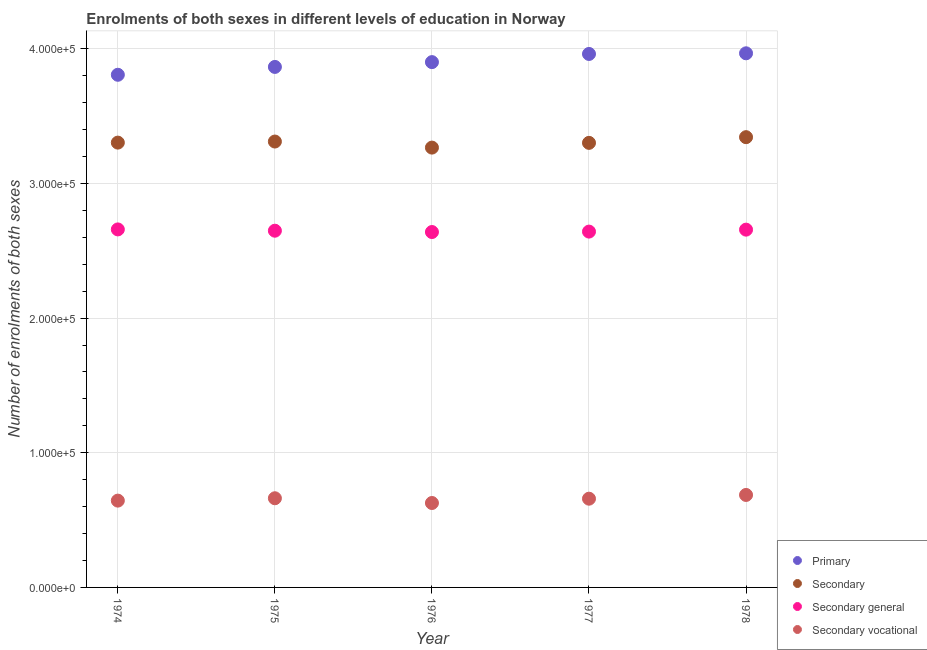How many different coloured dotlines are there?
Keep it short and to the point. 4. What is the number of enrolments in primary education in 1974?
Offer a very short reply. 3.81e+05. Across all years, what is the maximum number of enrolments in secondary education?
Offer a very short reply. 3.34e+05. Across all years, what is the minimum number of enrolments in secondary general education?
Make the answer very short. 2.64e+05. In which year was the number of enrolments in primary education maximum?
Your answer should be compact. 1978. In which year was the number of enrolments in primary education minimum?
Ensure brevity in your answer.  1974. What is the total number of enrolments in secondary education in the graph?
Offer a terse response. 1.65e+06. What is the difference between the number of enrolments in secondary general education in 1975 and that in 1978?
Give a very brief answer. -789. What is the difference between the number of enrolments in secondary vocational education in 1975 and the number of enrolments in secondary education in 1977?
Ensure brevity in your answer.  -2.64e+05. What is the average number of enrolments in secondary vocational education per year?
Your response must be concise. 6.56e+04. In the year 1974, what is the difference between the number of enrolments in primary education and number of enrolments in secondary general education?
Ensure brevity in your answer.  1.15e+05. What is the ratio of the number of enrolments in secondary vocational education in 1975 to that in 1978?
Your answer should be very brief. 0.96. Is the number of enrolments in primary education in 1975 less than that in 1978?
Your answer should be compact. Yes. What is the difference between the highest and the second highest number of enrolments in secondary general education?
Your answer should be very brief. 170. What is the difference between the highest and the lowest number of enrolments in secondary general education?
Provide a short and direct response. 1943. In how many years, is the number of enrolments in secondary general education greater than the average number of enrolments in secondary general education taken over all years?
Your response must be concise. 2. Is the sum of the number of enrolments in secondary vocational education in 1975 and 1978 greater than the maximum number of enrolments in secondary general education across all years?
Provide a short and direct response. No. Is the number of enrolments in secondary vocational education strictly greater than the number of enrolments in secondary general education over the years?
Ensure brevity in your answer.  No. How many dotlines are there?
Provide a short and direct response. 4. How many years are there in the graph?
Your response must be concise. 5. What is the difference between two consecutive major ticks on the Y-axis?
Provide a short and direct response. 1.00e+05. Does the graph contain any zero values?
Offer a very short reply. No. Where does the legend appear in the graph?
Your response must be concise. Bottom right. What is the title of the graph?
Your answer should be very brief. Enrolments of both sexes in different levels of education in Norway. What is the label or title of the X-axis?
Your answer should be compact. Year. What is the label or title of the Y-axis?
Keep it short and to the point. Number of enrolments of both sexes. What is the Number of enrolments of both sexes in Primary in 1974?
Your answer should be very brief. 3.81e+05. What is the Number of enrolments of both sexes in Secondary in 1974?
Your answer should be very brief. 3.30e+05. What is the Number of enrolments of both sexes of Secondary general in 1974?
Offer a very short reply. 2.66e+05. What is the Number of enrolments of both sexes in Secondary vocational in 1974?
Ensure brevity in your answer.  6.45e+04. What is the Number of enrolments of both sexes of Primary in 1975?
Ensure brevity in your answer.  3.87e+05. What is the Number of enrolments of both sexes in Secondary in 1975?
Your response must be concise. 3.31e+05. What is the Number of enrolments of both sexes in Secondary general in 1975?
Provide a succinct answer. 2.65e+05. What is the Number of enrolments of both sexes in Secondary vocational in 1975?
Your answer should be very brief. 6.62e+04. What is the Number of enrolments of both sexes in Primary in 1976?
Give a very brief answer. 3.90e+05. What is the Number of enrolments of both sexes in Secondary in 1976?
Offer a terse response. 3.27e+05. What is the Number of enrolments of both sexes of Secondary general in 1976?
Ensure brevity in your answer.  2.64e+05. What is the Number of enrolments of both sexes of Secondary vocational in 1976?
Give a very brief answer. 6.27e+04. What is the Number of enrolments of both sexes in Primary in 1977?
Offer a very short reply. 3.96e+05. What is the Number of enrolments of both sexes in Secondary in 1977?
Ensure brevity in your answer.  3.30e+05. What is the Number of enrolments of both sexes of Secondary general in 1977?
Your response must be concise. 2.64e+05. What is the Number of enrolments of both sexes in Secondary vocational in 1977?
Your answer should be compact. 6.59e+04. What is the Number of enrolments of both sexes in Primary in 1978?
Ensure brevity in your answer.  3.97e+05. What is the Number of enrolments of both sexes of Secondary in 1978?
Ensure brevity in your answer.  3.34e+05. What is the Number of enrolments of both sexes in Secondary general in 1978?
Make the answer very short. 2.66e+05. What is the Number of enrolments of both sexes of Secondary vocational in 1978?
Your answer should be compact. 6.87e+04. Across all years, what is the maximum Number of enrolments of both sexes in Primary?
Make the answer very short. 3.97e+05. Across all years, what is the maximum Number of enrolments of both sexes of Secondary?
Your answer should be very brief. 3.34e+05. Across all years, what is the maximum Number of enrolments of both sexes in Secondary general?
Your answer should be very brief. 2.66e+05. Across all years, what is the maximum Number of enrolments of both sexes of Secondary vocational?
Provide a short and direct response. 6.87e+04. Across all years, what is the minimum Number of enrolments of both sexes in Primary?
Your answer should be compact. 3.81e+05. Across all years, what is the minimum Number of enrolments of both sexes of Secondary?
Provide a short and direct response. 3.27e+05. Across all years, what is the minimum Number of enrolments of both sexes of Secondary general?
Your answer should be compact. 2.64e+05. Across all years, what is the minimum Number of enrolments of both sexes of Secondary vocational?
Provide a succinct answer. 6.27e+04. What is the total Number of enrolments of both sexes of Primary in the graph?
Your answer should be very brief. 1.95e+06. What is the total Number of enrolments of both sexes of Secondary in the graph?
Make the answer very short. 1.65e+06. What is the total Number of enrolments of both sexes of Secondary general in the graph?
Make the answer very short. 1.32e+06. What is the total Number of enrolments of both sexes of Secondary vocational in the graph?
Your answer should be very brief. 3.28e+05. What is the difference between the Number of enrolments of both sexes in Primary in 1974 and that in 1975?
Your answer should be compact. -5831. What is the difference between the Number of enrolments of both sexes in Secondary in 1974 and that in 1975?
Offer a very short reply. -799. What is the difference between the Number of enrolments of both sexes of Secondary general in 1974 and that in 1975?
Offer a very short reply. 959. What is the difference between the Number of enrolments of both sexes in Secondary vocational in 1974 and that in 1975?
Provide a short and direct response. -1758. What is the difference between the Number of enrolments of both sexes of Primary in 1974 and that in 1976?
Your answer should be compact. -9401. What is the difference between the Number of enrolments of both sexes in Secondary in 1974 and that in 1976?
Provide a short and direct response. 3710. What is the difference between the Number of enrolments of both sexes in Secondary general in 1974 and that in 1976?
Your response must be concise. 1943. What is the difference between the Number of enrolments of both sexes of Secondary vocational in 1974 and that in 1976?
Make the answer very short. 1767. What is the difference between the Number of enrolments of both sexes of Primary in 1974 and that in 1977?
Provide a succinct answer. -1.55e+04. What is the difference between the Number of enrolments of both sexes of Secondary in 1974 and that in 1977?
Keep it short and to the point. 187. What is the difference between the Number of enrolments of both sexes of Secondary general in 1974 and that in 1977?
Offer a very short reply. 1621. What is the difference between the Number of enrolments of both sexes of Secondary vocational in 1974 and that in 1977?
Keep it short and to the point. -1434. What is the difference between the Number of enrolments of both sexes of Primary in 1974 and that in 1978?
Keep it short and to the point. -1.59e+04. What is the difference between the Number of enrolments of both sexes of Secondary in 1974 and that in 1978?
Make the answer very short. -4042. What is the difference between the Number of enrolments of both sexes of Secondary general in 1974 and that in 1978?
Your answer should be very brief. 170. What is the difference between the Number of enrolments of both sexes in Secondary vocational in 1974 and that in 1978?
Your response must be concise. -4212. What is the difference between the Number of enrolments of both sexes in Primary in 1975 and that in 1976?
Give a very brief answer. -3570. What is the difference between the Number of enrolments of both sexes in Secondary in 1975 and that in 1976?
Make the answer very short. 4509. What is the difference between the Number of enrolments of both sexes of Secondary general in 1975 and that in 1976?
Your answer should be compact. 984. What is the difference between the Number of enrolments of both sexes of Secondary vocational in 1975 and that in 1976?
Offer a very short reply. 3525. What is the difference between the Number of enrolments of both sexes of Primary in 1975 and that in 1977?
Ensure brevity in your answer.  -9635. What is the difference between the Number of enrolments of both sexes in Secondary in 1975 and that in 1977?
Ensure brevity in your answer.  986. What is the difference between the Number of enrolments of both sexes in Secondary general in 1975 and that in 1977?
Make the answer very short. 662. What is the difference between the Number of enrolments of both sexes in Secondary vocational in 1975 and that in 1977?
Ensure brevity in your answer.  324. What is the difference between the Number of enrolments of both sexes of Primary in 1975 and that in 1978?
Offer a terse response. -1.01e+04. What is the difference between the Number of enrolments of both sexes of Secondary in 1975 and that in 1978?
Offer a terse response. -3243. What is the difference between the Number of enrolments of both sexes in Secondary general in 1975 and that in 1978?
Offer a very short reply. -789. What is the difference between the Number of enrolments of both sexes in Secondary vocational in 1975 and that in 1978?
Ensure brevity in your answer.  -2454. What is the difference between the Number of enrolments of both sexes of Primary in 1976 and that in 1977?
Keep it short and to the point. -6065. What is the difference between the Number of enrolments of both sexes of Secondary in 1976 and that in 1977?
Your response must be concise. -3523. What is the difference between the Number of enrolments of both sexes of Secondary general in 1976 and that in 1977?
Offer a very short reply. -322. What is the difference between the Number of enrolments of both sexes of Secondary vocational in 1976 and that in 1977?
Provide a succinct answer. -3201. What is the difference between the Number of enrolments of both sexes in Primary in 1976 and that in 1978?
Keep it short and to the point. -6543. What is the difference between the Number of enrolments of both sexes in Secondary in 1976 and that in 1978?
Make the answer very short. -7752. What is the difference between the Number of enrolments of both sexes in Secondary general in 1976 and that in 1978?
Keep it short and to the point. -1773. What is the difference between the Number of enrolments of both sexes of Secondary vocational in 1976 and that in 1978?
Provide a short and direct response. -5979. What is the difference between the Number of enrolments of both sexes of Primary in 1977 and that in 1978?
Keep it short and to the point. -478. What is the difference between the Number of enrolments of both sexes of Secondary in 1977 and that in 1978?
Ensure brevity in your answer.  -4229. What is the difference between the Number of enrolments of both sexes in Secondary general in 1977 and that in 1978?
Give a very brief answer. -1451. What is the difference between the Number of enrolments of both sexes of Secondary vocational in 1977 and that in 1978?
Make the answer very short. -2778. What is the difference between the Number of enrolments of both sexes of Primary in 1974 and the Number of enrolments of both sexes of Secondary in 1975?
Offer a terse response. 4.96e+04. What is the difference between the Number of enrolments of both sexes of Primary in 1974 and the Number of enrolments of both sexes of Secondary general in 1975?
Provide a succinct answer. 1.16e+05. What is the difference between the Number of enrolments of both sexes of Primary in 1974 and the Number of enrolments of both sexes of Secondary vocational in 1975?
Ensure brevity in your answer.  3.15e+05. What is the difference between the Number of enrolments of both sexes of Secondary in 1974 and the Number of enrolments of both sexes of Secondary general in 1975?
Your answer should be very brief. 6.54e+04. What is the difference between the Number of enrolments of both sexes of Secondary in 1974 and the Number of enrolments of both sexes of Secondary vocational in 1975?
Your answer should be compact. 2.64e+05. What is the difference between the Number of enrolments of both sexes in Secondary general in 1974 and the Number of enrolments of both sexes in Secondary vocational in 1975?
Provide a short and direct response. 2.00e+05. What is the difference between the Number of enrolments of both sexes in Primary in 1974 and the Number of enrolments of both sexes in Secondary in 1976?
Offer a very short reply. 5.41e+04. What is the difference between the Number of enrolments of both sexes in Primary in 1974 and the Number of enrolments of both sexes in Secondary general in 1976?
Provide a succinct answer. 1.17e+05. What is the difference between the Number of enrolments of both sexes of Primary in 1974 and the Number of enrolments of both sexes of Secondary vocational in 1976?
Keep it short and to the point. 3.18e+05. What is the difference between the Number of enrolments of both sexes in Secondary in 1974 and the Number of enrolments of both sexes in Secondary general in 1976?
Provide a succinct answer. 6.64e+04. What is the difference between the Number of enrolments of both sexes in Secondary in 1974 and the Number of enrolments of both sexes in Secondary vocational in 1976?
Make the answer very short. 2.68e+05. What is the difference between the Number of enrolments of both sexes of Secondary general in 1974 and the Number of enrolments of both sexes of Secondary vocational in 1976?
Your response must be concise. 2.03e+05. What is the difference between the Number of enrolments of both sexes of Primary in 1974 and the Number of enrolments of both sexes of Secondary in 1977?
Your answer should be compact. 5.06e+04. What is the difference between the Number of enrolments of both sexes of Primary in 1974 and the Number of enrolments of both sexes of Secondary general in 1977?
Your response must be concise. 1.16e+05. What is the difference between the Number of enrolments of both sexes in Primary in 1974 and the Number of enrolments of both sexes in Secondary vocational in 1977?
Offer a very short reply. 3.15e+05. What is the difference between the Number of enrolments of both sexes of Secondary in 1974 and the Number of enrolments of both sexes of Secondary general in 1977?
Make the answer very short. 6.61e+04. What is the difference between the Number of enrolments of both sexes of Secondary in 1974 and the Number of enrolments of both sexes of Secondary vocational in 1977?
Offer a very short reply. 2.64e+05. What is the difference between the Number of enrolments of both sexes of Secondary general in 1974 and the Number of enrolments of both sexes of Secondary vocational in 1977?
Your answer should be very brief. 2.00e+05. What is the difference between the Number of enrolments of both sexes of Primary in 1974 and the Number of enrolments of both sexes of Secondary in 1978?
Make the answer very short. 4.63e+04. What is the difference between the Number of enrolments of both sexes of Primary in 1974 and the Number of enrolments of both sexes of Secondary general in 1978?
Provide a short and direct response. 1.15e+05. What is the difference between the Number of enrolments of both sexes of Primary in 1974 and the Number of enrolments of both sexes of Secondary vocational in 1978?
Provide a succinct answer. 3.12e+05. What is the difference between the Number of enrolments of both sexes in Secondary in 1974 and the Number of enrolments of both sexes in Secondary general in 1978?
Ensure brevity in your answer.  6.46e+04. What is the difference between the Number of enrolments of both sexes in Secondary in 1974 and the Number of enrolments of both sexes in Secondary vocational in 1978?
Your response must be concise. 2.62e+05. What is the difference between the Number of enrolments of both sexes of Secondary general in 1974 and the Number of enrolments of both sexes of Secondary vocational in 1978?
Provide a short and direct response. 1.97e+05. What is the difference between the Number of enrolments of both sexes of Primary in 1975 and the Number of enrolments of both sexes of Secondary in 1976?
Offer a terse response. 5.99e+04. What is the difference between the Number of enrolments of both sexes of Primary in 1975 and the Number of enrolments of both sexes of Secondary general in 1976?
Make the answer very short. 1.23e+05. What is the difference between the Number of enrolments of both sexes in Primary in 1975 and the Number of enrolments of both sexes in Secondary vocational in 1976?
Provide a succinct answer. 3.24e+05. What is the difference between the Number of enrolments of both sexes in Secondary in 1975 and the Number of enrolments of both sexes in Secondary general in 1976?
Your response must be concise. 6.72e+04. What is the difference between the Number of enrolments of both sexes of Secondary in 1975 and the Number of enrolments of both sexes of Secondary vocational in 1976?
Make the answer very short. 2.68e+05. What is the difference between the Number of enrolments of both sexes in Secondary general in 1975 and the Number of enrolments of both sexes in Secondary vocational in 1976?
Ensure brevity in your answer.  2.02e+05. What is the difference between the Number of enrolments of both sexes in Primary in 1975 and the Number of enrolments of both sexes in Secondary in 1977?
Provide a succinct answer. 5.64e+04. What is the difference between the Number of enrolments of both sexes in Primary in 1975 and the Number of enrolments of both sexes in Secondary general in 1977?
Your response must be concise. 1.22e+05. What is the difference between the Number of enrolments of both sexes of Primary in 1975 and the Number of enrolments of both sexes of Secondary vocational in 1977?
Your response must be concise. 3.21e+05. What is the difference between the Number of enrolments of both sexes in Secondary in 1975 and the Number of enrolments of both sexes in Secondary general in 1977?
Offer a very short reply. 6.69e+04. What is the difference between the Number of enrolments of both sexes in Secondary in 1975 and the Number of enrolments of both sexes in Secondary vocational in 1977?
Make the answer very short. 2.65e+05. What is the difference between the Number of enrolments of both sexes of Secondary general in 1975 and the Number of enrolments of both sexes of Secondary vocational in 1977?
Ensure brevity in your answer.  1.99e+05. What is the difference between the Number of enrolments of both sexes in Primary in 1975 and the Number of enrolments of both sexes in Secondary in 1978?
Offer a very short reply. 5.22e+04. What is the difference between the Number of enrolments of both sexes in Primary in 1975 and the Number of enrolments of both sexes in Secondary general in 1978?
Give a very brief answer. 1.21e+05. What is the difference between the Number of enrolments of both sexes of Primary in 1975 and the Number of enrolments of both sexes of Secondary vocational in 1978?
Provide a succinct answer. 3.18e+05. What is the difference between the Number of enrolments of both sexes of Secondary in 1975 and the Number of enrolments of both sexes of Secondary general in 1978?
Ensure brevity in your answer.  6.54e+04. What is the difference between the Number of enrolments of both sexes of Secondary in 1975 and the Number of enrolments of both sexes of Secondary vocational in 1978?
Your answer should be very brief. 2.62e+05. What is the difference between the Number of enrolments of both sexes of Secondary general in 1975 and the Number of enrolments of both sexes of Secondary vocational in 1978?
Ensure brevity in your answer.  1.96e+05. What is the difference between the Number of enrolments of both sexes in Primary in 1976 and the Number of enrolments of both sexes in Secondary in 1977?
Make the answer very short. 6.00e+04. What is the difference between the Number of enrolments of both sexes of Primary in 1976 and the Number of enrolments of both sexes of Secondary general in 1977?
Your answer should be compact. 1.26e+05. What is the difference between the Number of enrolments of both sexes of Primary in 1976 and the Number of enrolments of both sexes of Secondary vocational in 1977?
Make the answer very short. 3.24e+05. What is the difference between the Number of enrolments of both sexes in Secondary in 1976 and the Number of enrolments of both sexes in Secondary general in 1977?
Your answer should be compact. 6.24e+04. What is the difference between the Number of enrolments of both sexes of Secondary in 1976 and the Number of enrolments of both sexes of Secondary vocational in 1977?
Offer a terse response. 2.61e+05. What is the difference between the Number of enrolments of both sexes in Secondary general in 1976 and the Number of enrolments of both sexes in Secondary vocational in 1977?
Your response must be concise. 1.98e+05. What is the difference between the Number of enrolments of both sexes in Primary in 1976 and the Number of enrolments of both sexes in Secondary in 1978?
Give a very brief answer. 5.57e+04. What is the difference between the Number of enrolments of both sexes in Primary in 1976 and the Number of enrolments of both sexes in Secondary general in 1978?
Offer a very short reply. 1.24e+05. What is the difference between the Number of enrolments of both sexes of Primary in 1976 and the Number of enrolments of both sexes of Secondary vocational in 1978?
Keep it short and to the point. 3.21e+05. What is the difference between the Number of enrolments of both sexes of Secondary in 1976 and the Number of enrolments of both sexes of Secondary general in 1978?
Give a very brief answer. 6.09e+04. What is the difference between the Number of enrolments of both sexes of Secondary in 1976 and the Number of enrolments of both sexes of Secondary vocational in 1978?
Offer a terse response. 2.58e+05. What is the difference between the Number of enrolments of both sexes of Secondary general in 1976 and the Number of enrolments of both sexes of Secondary vocational in 1978?
Provide a succinct answer. 1.95e+05. What is the difference between the Number of enrolments of both sexes of Primary in 1977 and the Number of enrolments of both sexes of Secondary in 1978?
Your answer should be very brief. 6.18e+04. What is the difference between the Number of enrolments of both sexes in Primary in 1977 and the Number of enrolments of both sexes in Secondary general in 1978?
Provide a short and direct response. 1.30e+05. What is the difference between the Number of enrolments of both sexes in Primary in 1977 and the Number of enrolments of both sexes in Secondary vocational in 1978?
Your response must be concise. 3.28e+05. What is the difference between the Number of enrolments of both sexes in Secondary in 1977 and the Number of enrolments of both sexes in Secondary general in 1978?
Give a very brief answer. 6.44e+04. What is the difference between the Number of enrolments of both sexes in Secondary in 1977 and the Number of enrolments of both sexes in Secondary vocational in 1978?
Ensure brevity in your answer.  2.61e+05. What is the difference between the Number of enrolments of both sexes of Secondary general in 1977 and the Number of enrolments of both sexes of Secondary vocational in 1978?
Your answer should be very brief. 1.96e+05. What is the average Number of enrolments of both sexes in Primary per year?
Your answer should be very brief. 3.90e+05. What is the average Number of enrolments of both sexes of Secondary per year?
Keep it short and to the point. 3.31e+05. What is the average Number of enrolments of both sexes in Secondary general per year?
Your answer should be very brief. 2.65e+05. What is the average Number of enrolments of both sexes in Secondary vocational per year?
Offer a very short reply. 6.56e+04. In the year 1974, what is the difference between the Number of enrolments of both sexes of Primary and Number of enrolments of both sexes of Secondary?
Provide a succinct answer. 5.04e+04. In the year 1974, what is the difference between the Number of enrolments of both sexes of Primary and Number of enrolments of both sexes of Secondary general?
Your response must be concise. 1.15e+05. In the year 1974, what is the difference between the Number of enrolments of both sexes in Primary and Number of enrolments of both sexes in Secondary vocational?
Your response must be concise. 3.16e+05. In the year 1974, what is the difference between the Number of enrolments of both sexes of Secondary and Number of enrolments of both sexes of Secondary general?
Give a very brief answer. 6.45e+04. In the year 1974, what is the difference between the Number of enrolments of both sexes of Secondary and Number of enrolments of both sexes of Secondary vocational?
Ensure brevity in your answer.  2.66e+05. In the year 1974, what is the difference between the Number of enrolments of both sexes in Secondary general and Number of enrolments of both sexes in Secondary vocational?
Offer a terse response. 2.01e+05. In the year 1975, what is the difference between the Number of enrolments of both sexes of Primary and Number of enrolments of both sexes of Secondary?
Your answer should be compact. 5.54e+04. In the year 1975, what is the difference between the Number of enrolments of both sexes in Primary and Number of enrolments of both sexes in Secondary general?
Offer a terse response. 1.22e+05. In the year 1975, what is the difference between the Number of enrolments of both sexes of Primary and Number of enrolments of both sexes of Secondary vocational?
Your response must be concise. 3.20e+05. In the year 1975, what is the difference between the Number of enrolments of both sexes of Secondary and Number of enrolments of both sexes of Secondary general?
Provide a succinct answer. 6.62e+04. In the year 1975, what is the difference between the Number of enrolments of both sexes of Secondary and Number of enrolments of both sexes of Secondary vocational?
Your answer should be compact. 2.65e+05. In the year 1975, what is the difference between the Number of enrolments of both sexes in Secondary general and Number of enrolments of both sexes in Secondary vocational?
Your answer should be compact. 1.99e+05. In the year 1976, what is the difference between the Number of enrolments of both sexes in Primary and Number of enrolments of both sexes in Secondary?
Your response must be concise. 6.35e+04. In the year 1976, what is the difference between the Number of enrolments of both sexes of Primary and Number of enrolments of both sexes of Secondary general?
Your answer should be very brief. 1.26e+05. In the year 1976, what is the difference between the Number of enrolments of both sexes of Primary and Number of enrolments of both sexes of Secondary vocational?
Your answer should be very brief. 3.27e+05. In the year 1976, what is the difference between the Number of enrolments of both sexes in Secondary and Number of enrolments of both sexes in Secondary general?
Your answer should be compact. 6.27e+04. In the year 1976, what is the difference between the Number of enrolments of both sexes in Secondary and Number of enrolments of both sexes in Secondary vocational?
Your answer should be very brief. 2.64e+05. In the year 1976, what is the difference between the Number of enrolments of both sexes of Secondary general and Number of enrolments of both sexes of Secondary vocational?
Your response must be concise. 2.01e+05. In the year 1977, what is the difference between the Number of enrolments of both sexes of Primary and Number of enrolments of both sexes of Secondary?
Provide a succinct answer. 6.60e+04. In the year 1977, what is the difference between the Number of enrolments of both sexes in Primary and Number of enrolments of both sexes in Secondary general?
Make the answer very short. 1.32e+05. In the year 1977, what is the difference between the Number of enrolments of both sexes in Primary and Number of enrolments of both sexes in Secondary vocational?
Provide a short and direct response. 3.30e+05. In the year 1977, what is the difference between the Number of enrolments of both sexes of Secondary and Number of enrolments of both sexes of Secondary general?
Your answer should be very brief. 6.59e+04. In the year 1977, what is the difference between the Number of enrolments of both sexes of Secondary and Number of enrolments of both sexes of Secondary vocational?
Your answer should be compact. 2.64e+05. In the year 1977, what is the difference between the Number of enrolments of both sexes in Secondary general and Number of enrolments of both sexes in Secondary vocational?
Provide a succinct answer. 1.98e+05. In the year 1978, what is the difference between the Number of enrolments of both sexes in Primary and Number of enrolments of both sexes in Secondary?
Your response must be concise. 6.23e+04. In the year 1978, what is the difference between the Number of enrolments of both sexes in Primary and Number of enrolments of both sexes in Secondary general?
Your response must be concise. 1.31e+05. In the year 1978, what is the difference between the Number of enrolments of both sexes of Primary and Number of enrolments of both sexes of Secondary vocational?
Offer a terse response. 3.28e+05. In the year 1978, what is the difference between the Number of enrolments of both sexes of Secondary and Number of enrolments of both sexes of Secondary general?
Your answer should be very brief. 6.87e+04. In the year 1978, what is the difference between the Number of enrolments of both sexes of Secondary and Number of enrolments of both sexes of Secondary vocational?
Make the answer very short. 2.66e+05. In the year 1978, what is the difference between the Number of enrolments of both sexes of Secondary general and Number of enrolments of both sexes of Secondary vocational?
Your response must be concise. 1.97e+05. What is the ratio of the Number of enrolments of both sexes in Primary in 1974 to that in 1975?
Offer a terse response. 0.98. What is the ratio of the Number of enrolments of both sexes of Secondary in 1974 to that in 1975?
Your response must be concise. 1. What is the ratio of the Number of enrolments of both sexes of Secondary vocational in 1974 to that in 1975?
Provide a short and direct response. 0.97. What is the ratio of the Number of enrolments of both sexes of Primary in 1974 to that in 1976?
Ensure brevity in your answer.  0.98. What is the ratio of the Number of enrolments of both sexes in Secondary in 1974 to that in 1976?
Ensure brevity in your answer.  1.01. What is the ratio of the Number of enrolments of both sexes of Secondary general in 1974 to that in 1976?
Offer a very short reply. 1.01. What is the ratio of the Number of enrolments of both sexes in Secondary vocational in 1974 to that in 1976?
Your answer should be very brief. 1.03. What is the ratio of the Number of enrolments of both sexes in Primary in 1974 to that in 1977?
Provide a short and direct response. 0.96. What is the ratio of the Number of enrolments of both sexes of Secondary vocational in 1974 to that in 1977?
Provide a short and direct response. 0.98. What is the ratio of the Number of enrolments of both sexes of Primary in 1974 to that in 1978?
Offer a very short reply. 0.96. What is the ratio of the Number of enrolments of both sexes of Secondary in 1974 to that in 1978?
Provide a succinct answer. 0.99. What is the ratio of the Number of enrolments of both sexes in Secondary vocational in 1974 to that in 1978?
Make the answer very short. 0.94. What is the ratio of the Number of enrolments of both sexes in Secondary in 1975 to that in 1976?
Your answer should be compact. 1.01. What is the ratio of the Number of enrolments of both sexes in Secondary vocational in 1975 to that in 1976?
Offer a terse response. 1.06. What is the ratio of the Number of enrolments of both sexes in Primary in 1975 to that in 1977?
Offer a terse response. 0.98. What is the ratio of the Number of enrolments of both sexes of Secondary in 1975 to that in 1977?
Provide a succinct answer. 1. What is the ratio of the Number of enrolments of both sexes of Secondary general in 1975 to that in 1977?
Keep it short and to the point. 1. What is the ratio of the Number of enrolments of both sexes of Secondary vocational in 1975 to that in 1977?
Offer a terse response. 1. What is the ratio of the Number of enrolments of both sexes of Primary in 1975 to that in 1978?
Give a very brief answer. 0.97. What is the ratio of the Number of enrolments of both sexes in Secondary in 1975 to that in 1978?
Provide a succinct answer. 0.99. What is the ratio of the Number of enrolments of both sexes in Secondary general in 1975 to that in 1978?
Make the answer very short. 1. What is the ratio of the Number of enrolments of both sexes in Primary in 1976 to that in 1977?
Ensure brevity in your answer.  0.98. What is the ratio of the Number of enrolments of both sexes in Secondary in 1976 to that in 1977?
Your answer should be compact. 0.99. What is the ratio of the Number of enrolments of both sexes in Secondary vocational in 1976 to that in 1977?
Provide a succinct answer. 0.95. What is the ratio of the Number of enrolments of both sexes of Primary in 1976 to that in 1978?
Keep it short and to the point. 0.98. What is the ratio of the Number of enrolments of both sexes of Secondary in 1976 to that in 1978?
Provide a succinct answer. 0.98. What is the ratio of the Number of enrolments of both sexes of Secondary general in 1976 to that in 1978?
Ensure brevity in your answer.  0.99. What is the ratio of the Number of enrolments of both sexes of Secondary vocational in 1976 to that in 1978?
Offer a terse response. 0.91. What is the ratio of the Number of enrolments of both sexes in Secondary in 1977 to that in 1978?
Provide a short and direct response. 0.99. What is the ratio of the Number of enrolments of both sexes in Secondary general in 1977 to that in 1978?
Ensure brevity in your answer.  0.99. What is the ratio of the Number of enrolments of both sexes of Secondary vocational in 1977 to that in 1978?
Make the answer very short. 0.96. What is the difference between the highest and the second highest Number of enrolments of both sexes in Primary?
Your response must be concise. 478. What is the difference between the highest and the second highest Number of enrolments of both sexes in Secondary?
Your answer should be very brief. 3243. What is the difference between the highest and the second highest Number of enrolments of both sexes in Secondary general?
Make the answer very short. 170. What is the difference between the highest and the second highest Number of enrolments of both sexes in Secondary vocational?
Your answer should be compact. 2454. What is the difference between the highest and the lowest Number of enrolments of both sexes of Primary?
Provide a succinct answer. 1.59e+04. What is the difference between the highest and the lowest Number of enrolments of both sexes in Secondary?
Offer a very short reply. 7752. What is the difference between the highest and the lowest Number of enrolments of both sexes in Secondary general?
Keep it short and to the point. 1943. What is the difference between the highest and the lowest Number of enrolments of both sexes in Secondary vocational?
Provide a succinct answer. 5979. 